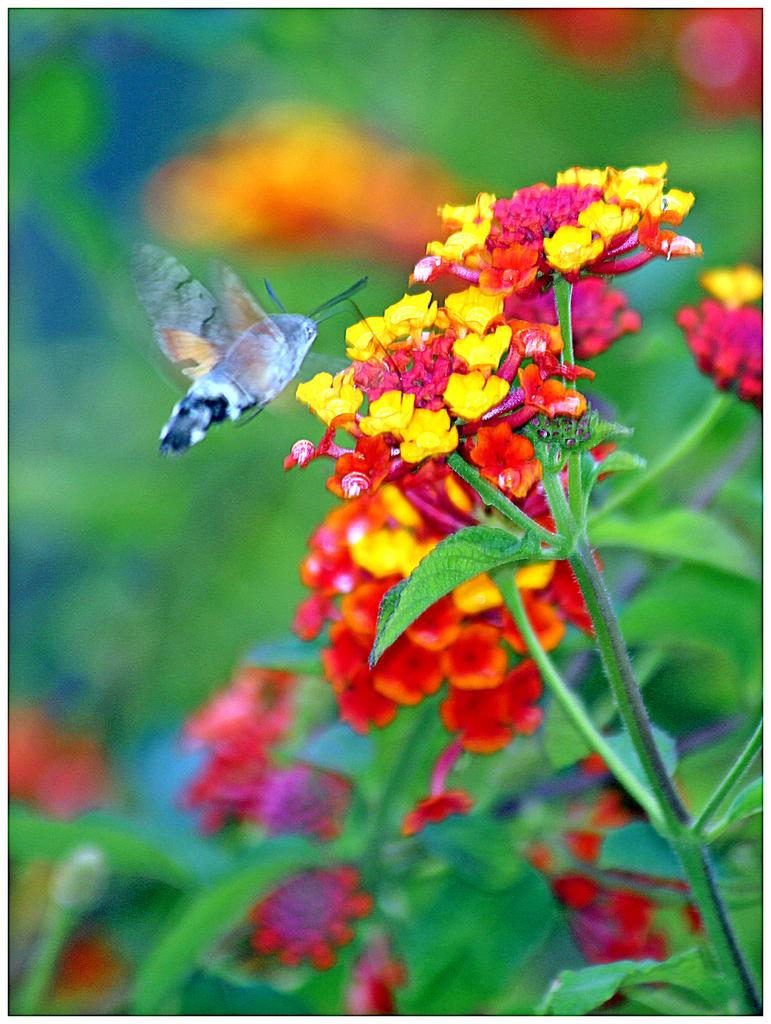What is the main subject of the picture? The main subject of the picture is a butterfly. What is the butterfly doing in the picture? The butterfly is flying near flowers in the picture. Can you describe the flowers in the image? There are yellow and red flowers on a plant in the picture. Where are the flowers located in the image? The flowers are on the right side of the image. What else can be seen at the bottom of the image? There are leaves visible at the bottom of the image. What type of trouble is the butterfly causing in the image? There is no indication of trouble or any negative actions in the image; the butterfly is simply flying near flowers. Is the butterfly reading a book in the image? There is no book or any reading material present in the image; the butterfly is flying near flowers. 